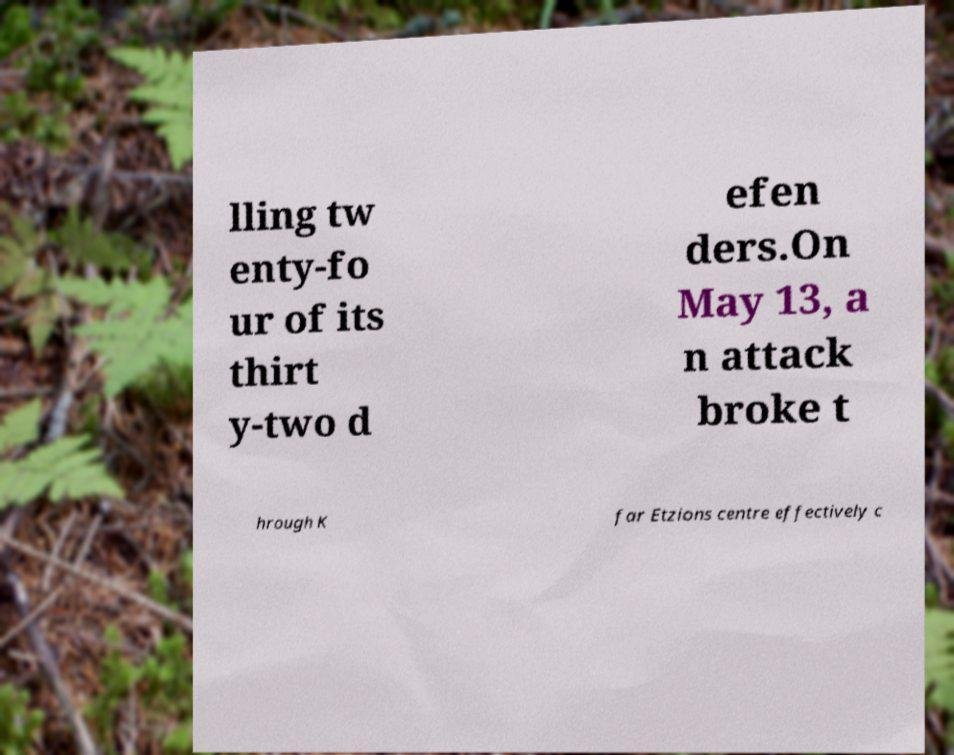For documentation purposes, I need the text within this image transcribed. Could you provide that? lling tw enty-fo ur of its thirt y-two d efen ders.On May 13, a n attack broke t hrough K far Etzions centre effectively c 